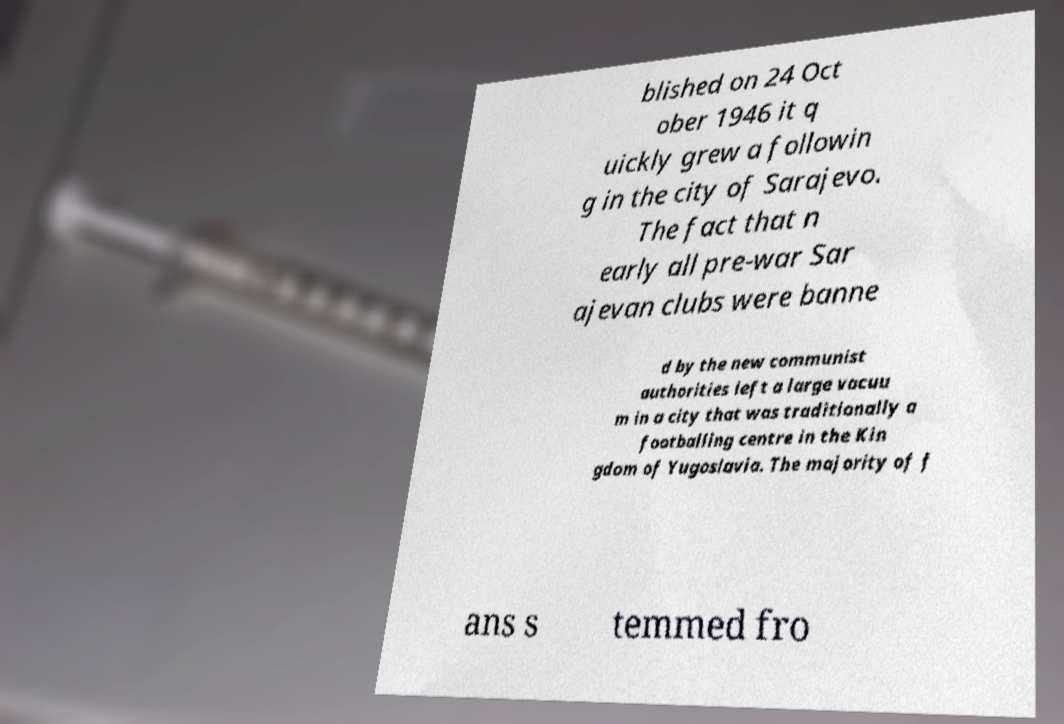For documentation purposes, I need the text within this image transcribed. Could you provide that? blished on 24 Oct ober 1946 it q uickly grew a followin g in the city of Sarajevo. The fact that n early all pre-war Sar ajevan clubs were banne d by the new communist authorities left a large vacuu m in a city that was traditionally a footballing centre in the Kin gdom of Yugoslavia. The majority of f ans s temmed fro 